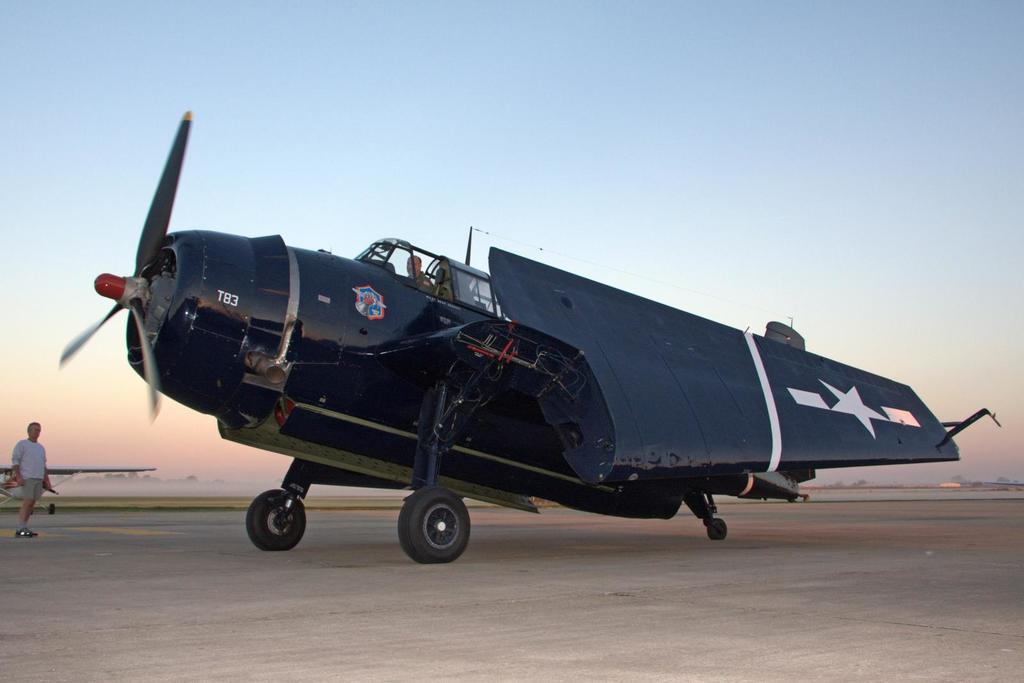<image>
Share a concise interpretation of the image provided. A large plane is marked T83 and someone stands nearby. 